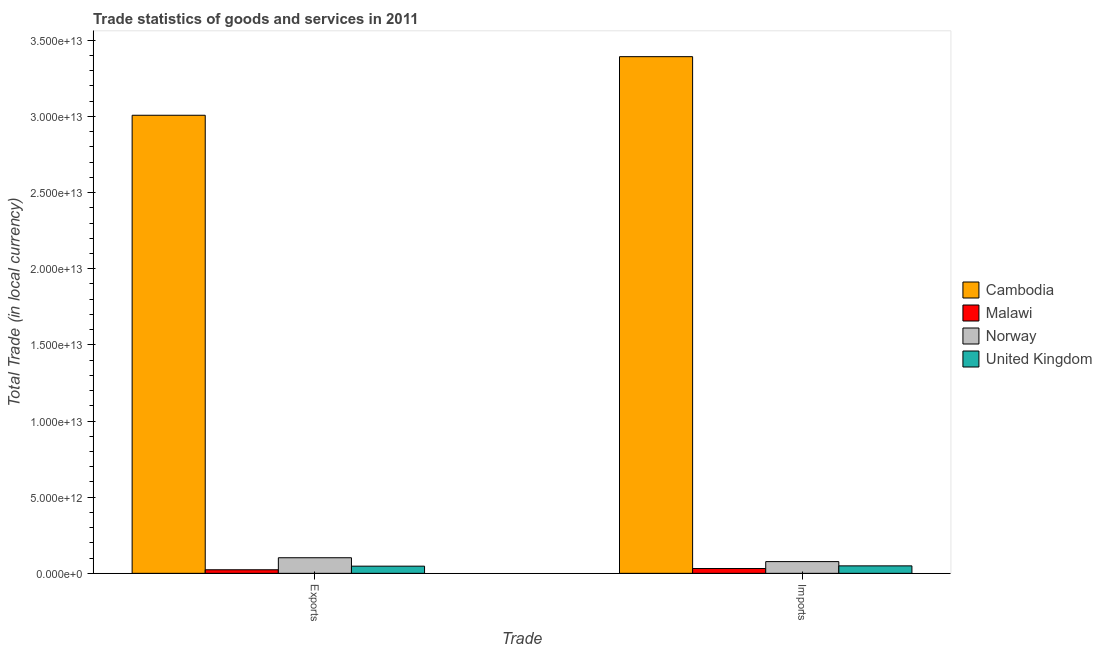What is the label of the 2nd group of bars from the left?
Provide a short and direct response. Imports. What is the imports of goods and services in Malawi?
Offer a terse response. 3.15e+11. Across all countries, what is the maximum export of goods and services?
Make the answer very short. 3.01e+13. Across all countries, what is the minimum imports of goods and services?
Give a very brief answer. 3.15e+11. In which country was the imports of goods and services maximum?
Offer a very short reply. Cambodia. In which country was the export of goods and services minimum?
Offer a very short reply. Malawi. What is the total export of goods and services in the graph?
Provide a succinct answer. 3.18e+13. What is the difference between the imports of goods and services in Malawi and that in Norway?
Make the answer very short. -4.54e+11. What is the difference between the export of goods and services in Cambodia and the imports of goods and services in Malawi?
Provide a short and direct response. 2.98e+13. What is the average export of goods and services per country?
Provide a short and direct response. 7.95e+12. What is the difference between the imports of goods and services and export of goods and services in Norway?
Offer a very short reply. -2.54e+11. In how many countries, is the imports of goods and services greater than 27000000000000 LCU?
Your answer should be compact. 1. What is the ratio of the export of goods and services in Malawi to that in United Kingdom?
Provide a short and direct response. 0.5. Is the imports of goods and services in Cambodia less than that in United Kingdom?
Your answer should be very brief. No. What does the 2nd bar from the left in Exports represents?
Provide a succinct answer. Malawi. What does the 4th bar from the right in Imports represents?
Your answer should be very brief. Cambodia. Are all the bars in the graph horizontal?
Give a very brief answer. No. How many countries are there in the graph?
Offer a very short reply. 4. What is the difference between two consecutive major ticks on the Y-axis?
Your answer should be very brief. 5.00e+12. Are the values on the major ticks of Y-axis written in scientific E-notation?
Ensure brevity in your answer.  Yes. Does the graph contain grids?
Your answer should be compact. No. How many legend labels are there?
Ensure brevity in your answer.  4. How are the legend labels stacked?
Your response must be concise. Vertical. What is the title of the graph?
Offer a terse response. Trade statistics of goods and services in 2011. What is the label or title of the X-axis?
Your answer should be compact. Trade. What is the label or title of the Y-axis?
Your answer should be very brief. Total Trade (in local currency). What is the Total Trade (in local currency) in Cambodia in Exports?
Make the answer very short. 3.01e+13. What is the Total Trade (in local currency) of Malawi in Exports?
Give a very brief answer. 2.34e+11. What is the Total Trade (in local currency) in Norway in Exports?
Ensure brevity in your answer.  1.02e+12. What is the Total Trade (in local currency) of United Kingdom in Exports?
Give a very brief answer. 4.70e+11. What is the Total Trade (in local currency) of Cambodia in Imports?
Make the answer very short. 3.39e+13. What is the Total Trade (in local currency) in Malawi in Imports?
Give a very brief answer. 3.15e+11. What is the Total Trade (in local currency) of Norway in Imports?
Your answer should be compact. 7.70e+11. What is the Total Trade (in local currency) in United Kingdom in Imports?
Your answer should be very brief. 4.90e+11. Across all Trade, what is the maximum Total Trade (in local currency) in Cambodia?
Your answer should be very brief. 3.39e+13. Across all Trade, what is the maximum Total Trade (in local currency) of Malawi?
Offer a terse response. 3.15e+11. Across all Trade, what is the maximum Total Trade (in local currency) of Norway?
Offer a terse response. 1.02e+12. Across all Trade, what is the maximum Total Trade (in local currency) in United Kingdom?
Ensure brevity in your answer.  4.90e+11. Across all Trade, what is the minimum Total Trade (in local currency) in Cambodia?
Provide a short and direct response. 3.01e+13. Across all Trade, what is the minimum Total Trade (in local currency) in Malawi?
Offer a very short reply. 2.34e+11. Across all Trade, what is the minimum Total Trade (in local currency) of Norway?
Make the answer very short. 7.70e+11. Across all Trade, what is the minimum Total Trade (in local currency) of United Kingdom?
Provide a succinct answer. 4.70e+11. What is the total Total Trade (in local currency) of Cambodia in the graph?
Offer a terse response. 6.40e+13. What is the total Total Trade (in local currency) in Malawi in the graph?
Your answer should be compact. 5.49e+11. What is the total Total Trade (in local currency) in Norway in the graph?
Your answer should be compact. 1.79e+12. What is the total Total Trade (in local currency) of United Kingdom in the graph?
Your response must be concise. 9.60e+11. What is the difference between the Total Trade (in local currency) of Cambodia in Exports and that in Imports?
Offer a terse response. -3.85e+12. What is the difference between the Total Trade (in local currency) of Malawi in Exports and that in Imports?
Your answer should be compact. -8.15e+1. What is the difference between the Total Trade (in local currency) in Norway in Exports and that in Imports?
Your answer should be very brief. 2.54e+11. What is the difference between the Total Trade (in local currency) of United Kingdom in Exports and that in Imports?
Offer a terse response. -1.98e+1. What is the difference between the Total Trade (in local currency) in Cambodia in Exports and the Total Trade (in local currency) in Malawi in Imports?
Offer a very short reply. 2.98e+13. What is the difference between the Total Trade (in local currency) in Cambodia in Exports and the Total Trade (in local currency) in Norway in Imports?
Give a very brief answer. 2.93e+13. What is the difference between the Total Trade (in local currency) of Cambodia in Exports and the Total Trade (in local currency) of United Kingdom in Imports?
Provide a succinct answer. 2.96e+13. What is the difference between the Total Trade (in local currency) of Malawi in Exports and the Total Trade (in local currency) of Norway in Imports?
Keep it short and to the point. -5.36e+11. What is the difference between the Total Trade (in local currency) of Malawi in Exports and the Total Trade (in local currency) of United Kingdom in Imports?
Your answer should be compact. -2.56e+11. What is the difference between the Total Trade (in local currency) in Norway in Exports and the Total Trade (in local currency) in United Kingdom in Imports?
Make the answer very short. 5.33e+11. What is the average Total Trade (in local currency) in Cambodia per Trade?
Offer a very short reply. 3.20e+13. What is the average Total Trade (in local currency) of Malawi per Trade?
Offer a terse response. 2.75e+11. What is the average Total Trade (in local currency) of Norway per Trade?
Your answer should be compact. 8.97e+11. What is the average Total Trade (in local currency) in United Kingdom per Trade?
Your response must be concise. 4.80e+11. What is the difference between the Total Trade (in local currency) of Cambodia and Total Trade (in local currency) of Malawi in Exports?
Ensure brevity in your answer.  2.98e+13. What is the difference between the Total Trade (in local currency) of Cambodia and Total Trade (in local currency) of Norway in Exports?
Give a very brief answer. 2.91e+13. What is the difference between the Total Trade (in local currency) in Cambodia and Total Trade (in local currency) in United Kingdom in Exports?
Ensure brevity in your answer.  2.96e+13. What is the difference between the Total Trade (in local currency) of Malawi and Total Trade (in local currency) of Norway in Exports?
Provide a short and direct response. -7.89e+11. What is the difference between the Total Trade (in local currency) in Malawi and Total Trade (in local currency) in United Kingdom in Exports?
Keep it short and to the point. -2.36e+11. What is the difference between the Total Trade (in local currency) of Norway and Total Trade (in local currency) of United Kingdom in Exports?
Provide a short and direct response. 5.53e+11. What is the difference between the Total Trade (in local currency) of Cambodia and Total Trade (in local currency) of Malawi in Imports?
Make the answer very short. 3.36e+13. What is the difference between the Total Trade (in local currency) of Cambodia and Total Trade (in local currency) of Norway in Imports?
Make the answer very short. 3.32e+13. What is the difference between the Total Trade (in local currency) in Cambodia and Total Trade (in local currency) in United Kingdom in Imports?
Your answer should be compact. 3.34e+13. What is the difference between the Total Trade (in local currency) in Malawi and Total Trade (in local currency) in Norway in Imports?
Keep it short and to the point. -4.54e+11. What is the difference between the Total Trade (in local currency) of Malawi and Total Trade (in local currency) of United Kingdom in Imports?
Offer a terse response. -1.75e+11. What is the difference between the Total Trade (in local currency) in Norway and Total Trade (in local currency) in United Kingdom in Imports?
Offer a terse response. 2.80e+11. What is the ratio of the Total Trade (in local currency) of Cambodia in Exports to that in Imports?
Your answer should be compact. 0.89. What is the ratio of the Total Trade (in local currency) in Malawi in Exports to that in Imports?
Keep it short and to the point. 0.74. What is the ratio of the Total Trade (in local currency) in Norway in Exports to that in Imports?
Offer a very short reply. 1.33. What is the ratio of the Total Trade (in local currency) of United Kingdom in Exports to that in Imports?
Make the answer very short. 0.96. What is the difference between the highest and the second highest Total Trade (in local currency) of Cambodia?
Your answer should be very brief. 3.85e+12. What is the difference between the highest and the second highest Total Trade (in local currency) of Malawi?
Give a very brief answer. 8.15e+1. What is the difference between the highest and the second highest Total Trade (in local currency) in Norway?
Provide a succinct answer. 2.54e+11. What is the difference between the highest and the second highest Total Trade (in local currency) in United Kingdom?
Make the answer very short. 1.98e+1. What is the difference between the highest and the lowest Total Trade (in local currency) in Cambodia?
Offer a very short reply. 3.85e+12. What is the difference between the highest and the lowest Total Trade (in local currency) in Malawi?
Ensure brevity in your answer.  8.15e+1. What is the difference between the highest and the lowest Total Trade (in local currency) in Norway?
Offer a very short reply. 2.54e+11. What is the difference between the highest and the lowest Total Trade (in local currency) in United Kingdom?
Ensure brevity in your answer.  1.98e+1. 